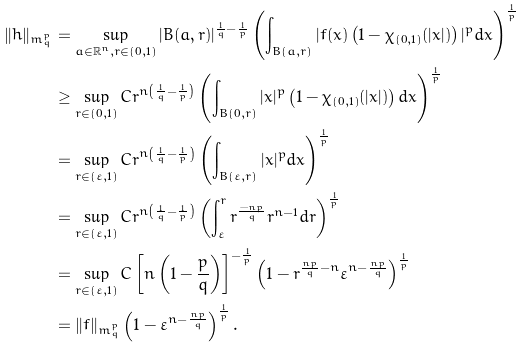<formula> <loc_0><loc_0><loc_500><loc_500>\| h \| _ { m ^ { p } _ { q } } & = \sup _ { a \in \mathbb { R } ^ { n } , r \in ( 0 , 1 ) } | B ( a , r ) | ^ { \frac { 1 } { q } - \frac { 1 } { p } } \left ( \int _ { B ( a , r ) } | f ( x ) \left ( 1 - \chi _ { ( 0 , 1 ) } ( | x | ) \right ) | ^ { p } d x \right ) ^ { \frac { 1 } { p } } \\ & \geq \sup _ { r \in ( 0 , 1 ) } C r ^ { n \left ( \frac { 1 } { q } - \frac { 1 } { p } \right ) } \left ( \int _ { B ( 0 , r ) } | x | ^ { p } \left ( 1 - \chi _ { ( 0 , 1 ) } ( | x | ) \right ) d x \right ) ^ { \frac { 1 } { p } } \\ & = \sup _ { r \in ( \varepsilon , 1 ) } C r ^ { n \left ( \frac { 1 } { q } - \frac { 1 } { p } \right ) } \left ( \int _ { B ( \varepsilon , r ) } | x | ^ { p } d x \right ) ^ { \frac { 1 } { p } } \\ & = \sup _ { r \in ( \varepsilon , 1 ) } C r ^ { n \left ( \frac { 1 } { q } - \frac { 1 } { p } \right ) } \left ( \int _ { \varepsilon } ^ { r } r ^ { \frac { - n p } { q } } r ^ { n - 1 } d r \right ) ^ { \frac { 1 } { p } } \\ & = \sup _ { r \in ( \varepsilon , 1 ) } C \left [ n \left ( 1 - \frac { p } { q } \right ) \right ] ^ { - \frac { 1 } { p } } \left ( 1 - r ^ { \frac { n p } { q } - n } \varepsilon ^ { n - \frac { n p } { q } } \right ) ^ { \frac { 1 } { p } } \\ & = \| f \| _ { m ^ { p } _ { q } } \left ( 1 - \varepsilon ^ { n - \frac { n p } { q } } \right ) ^ { \frac { 1 } { p } } .</formula> 